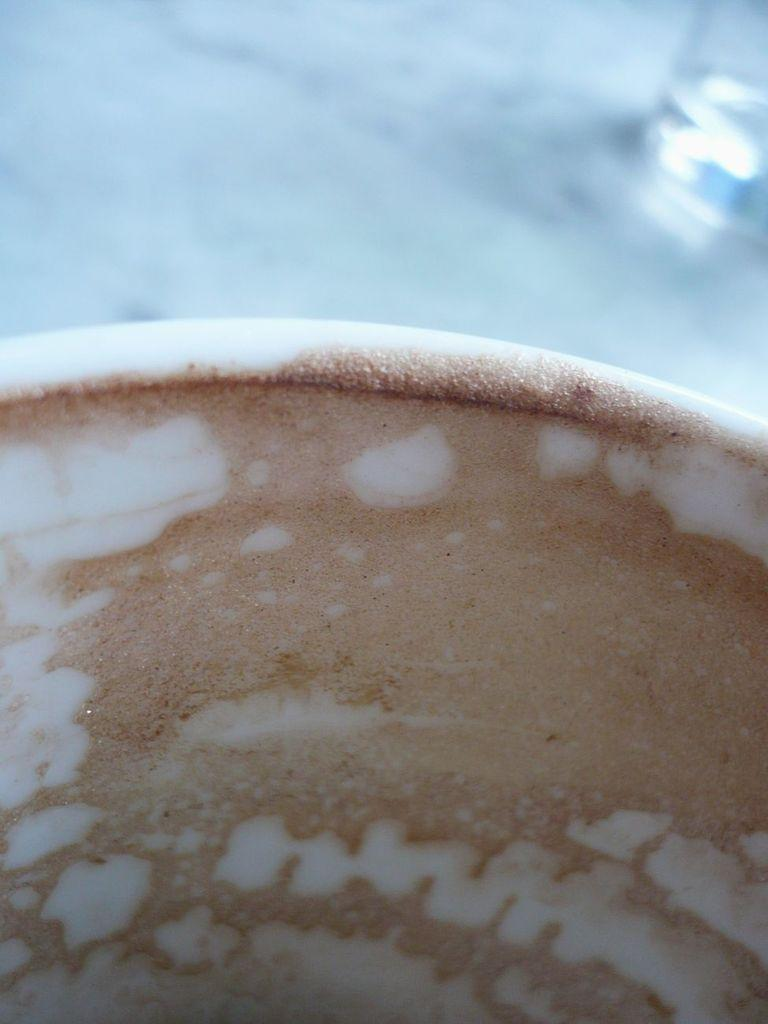What is in the cup that is visible in the image? There is a cup with coffee in the image. What other container can be seen in the image? There is a glass on a white surface in the image. What type of badge is the spy wearing in the image? There is no badge or spy present in the image; it only features a cup with coffee and a glass on a white surface. 